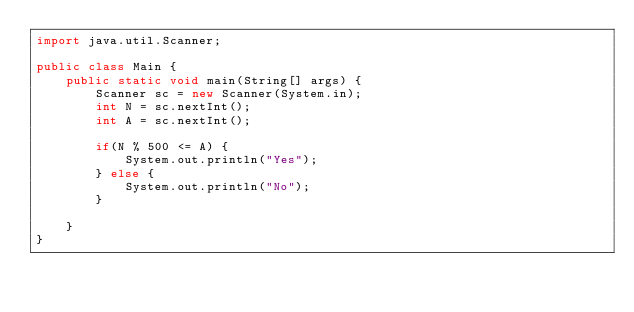Convert code to text. <code><loc_0><loc_0><loc_500><loc_500><_Java_>import java.util.Scanner;

public class Main {
	public static void main(String[] args) {
		Scanner sc = new Scanner(System.in);
		int N = sc.nextInt();
		int A = sc.nextInt();
		
		if(N % 500 <= A) {
			System.out.println("Yes");
		} else {
			System.out.println("No");
		}
		
	}
}
</code> 